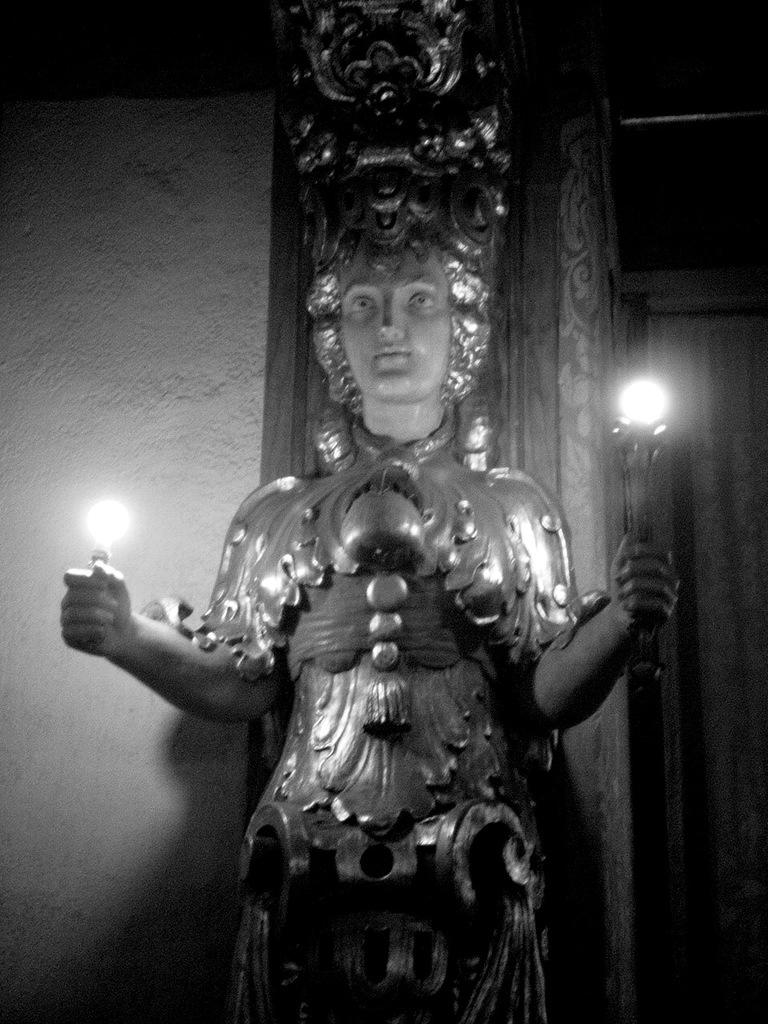What is: What is the main subject of the image? There is an idol of a woman in the image. What other objects can be seen in the image? There are two lamps in the image. What is visible in the background of the image? There is a wall in the background of the image. What type of wristwatch is the laborer wearing during the holiday in the image? There is no laborer, wristwatch, or holiday depicted in the image; it features an idol of a woman and two lamps with a wall in the background. 